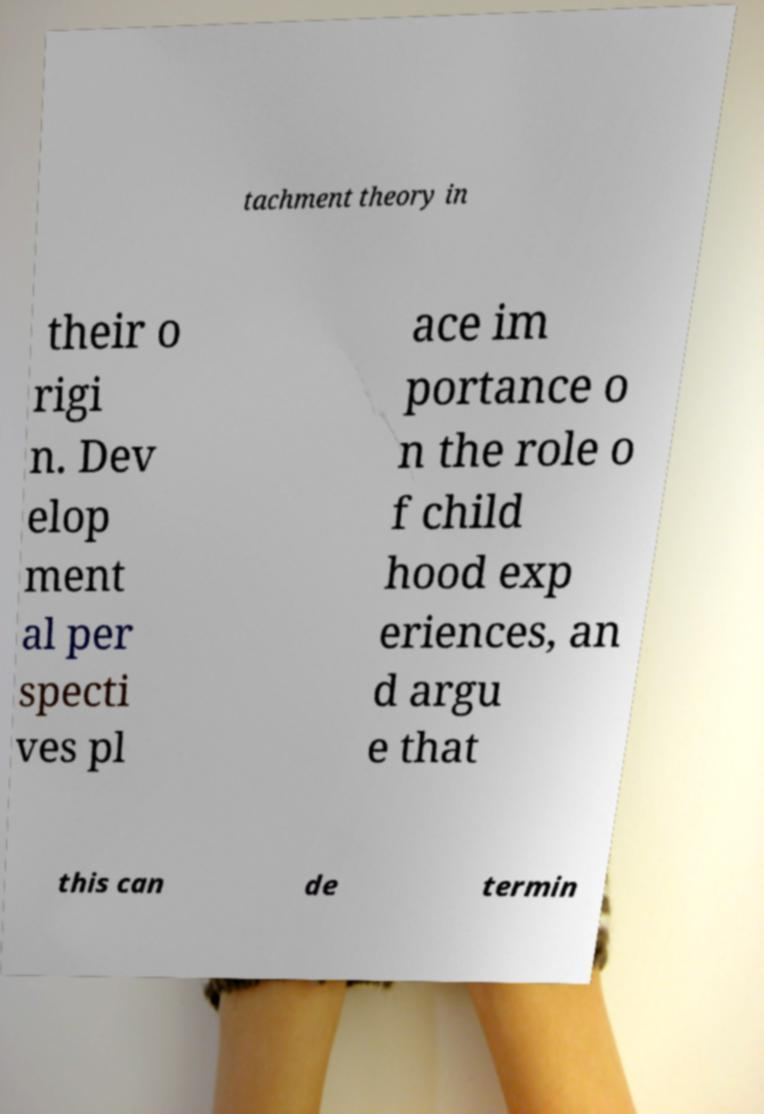Could you assist in decoding the text presented in this image and type it out clearly? tachment theory in their o rigi n. Dev elop ment al per specti ves pl ace im portance o n the role o f child hood exp eriences, an d argu e that this can de termin 